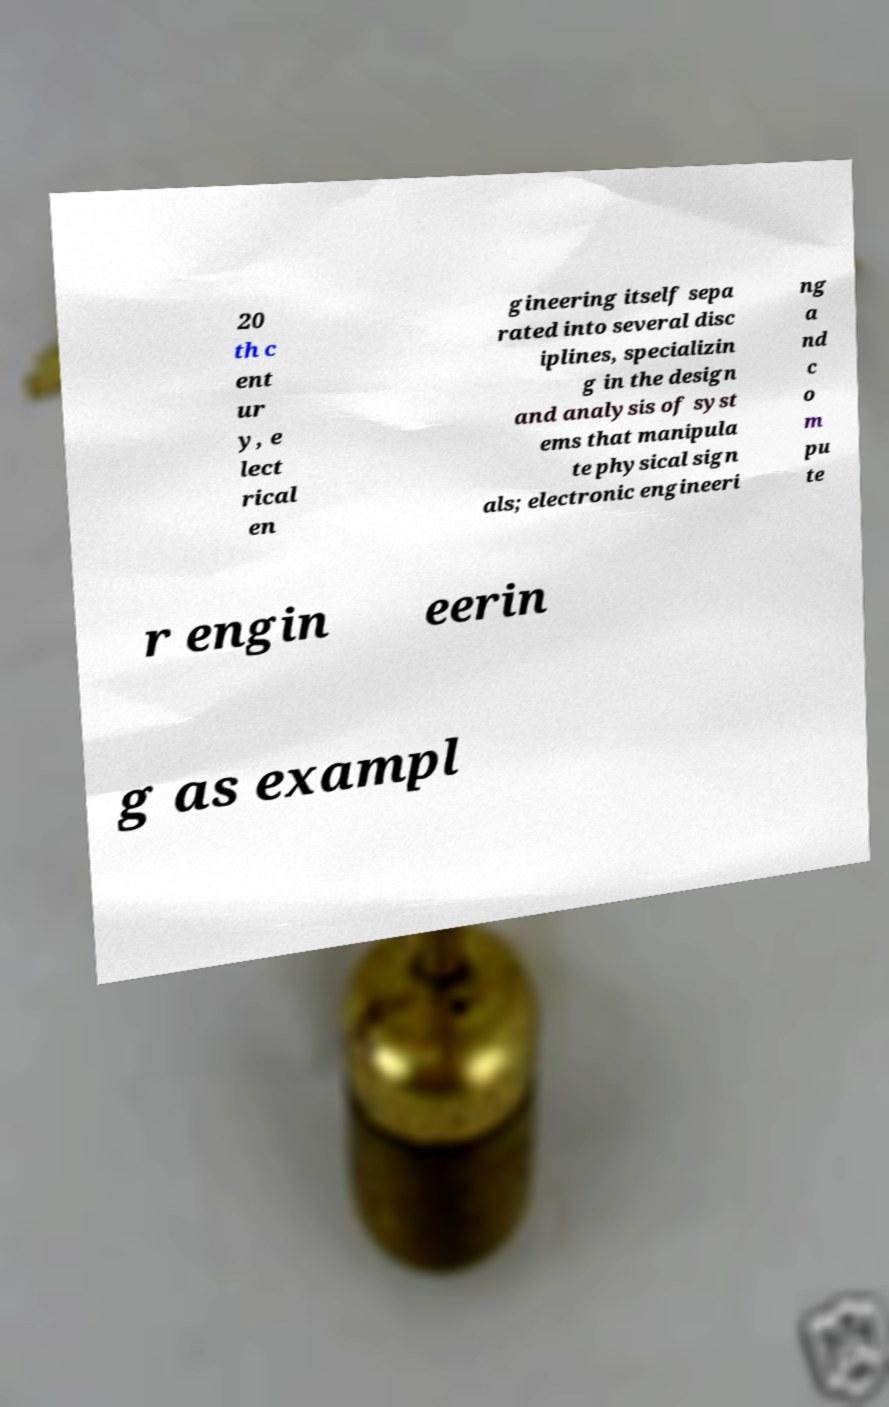Please identify and transcribe the text found in this image. 20 th c ent ur y, e lect rical en gineering itself sepa rated into several disc iplines, specializin g in the design and analysis of syst ems that manipula te physical sign als; electronic engineeri ng a nd c o m pu te r engin eerin g as exampl 